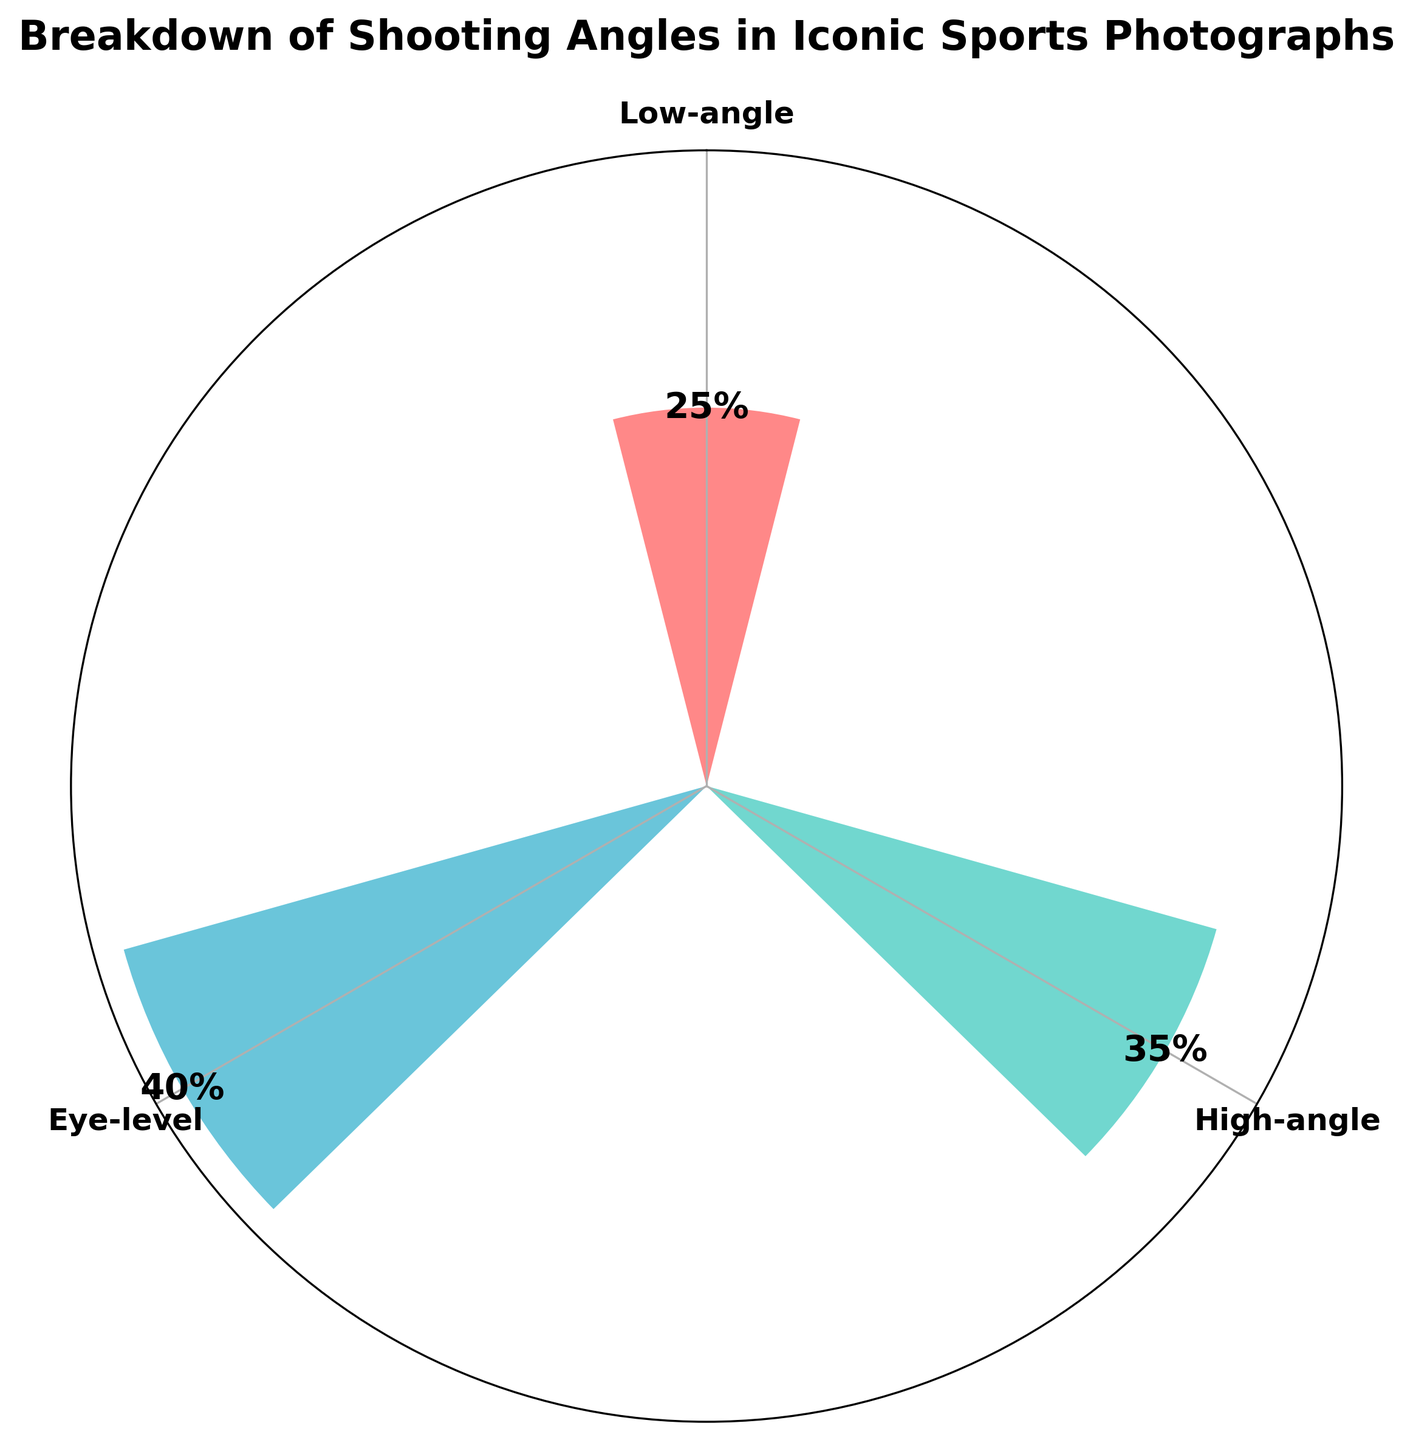What is the title of the rose chart? The title can be found at the top of the figure. It describes the main subject of the chart.
Answer: Breakdown of Shooting Angles in Iconic Sports Photographs Which group has the highest percentage of iconic sports photographs? Identify the bar with the highest radial length. Its angle label will indicate the group.
Answer: Eye-level What percentage of iconic sports photographs are taken from a high angle? Locate the bar corresponding to "High-angle" and read the label or its height.
Answer: 35% What is the combined percentage of iconic sports photographs taken from low and high angles? Add the percentages of both low-angle and high-angle shots: 25% + 35%.
Answer: 60% Compare the percentage of eye-level photographs to low-angle photographs. Which is greater and by how much? Subtract the low-angle percentage from the eye-level percentage: 40% - 25%.
Answer: Eye-level by 15% Which group has the smallest percentage of iconic sports photographs? Identify the bar with the shortest radial length and read the angle label.
Answer: Low-angle Add the percentages of all shooting angles. What is the total? Sum the percentages of all groups: 25% + 35% + 40%.
Answer: 100% What color represents high-angle shots in the rose chart? Observe the color of the bar labeled "High-angle."
Answer: Teal (or a similar description of #4ECDC4) How is the direction of angle rotation set in the rose chart? Infer the rotation direction based on the placement of angle labels clockwise or counterclockwise.
Answer: Counterclockwise Identify the label for the 25% marking in the rose chart. Locate the bar with the smallest height and find its corresponding label.
Answer: Low-angle 